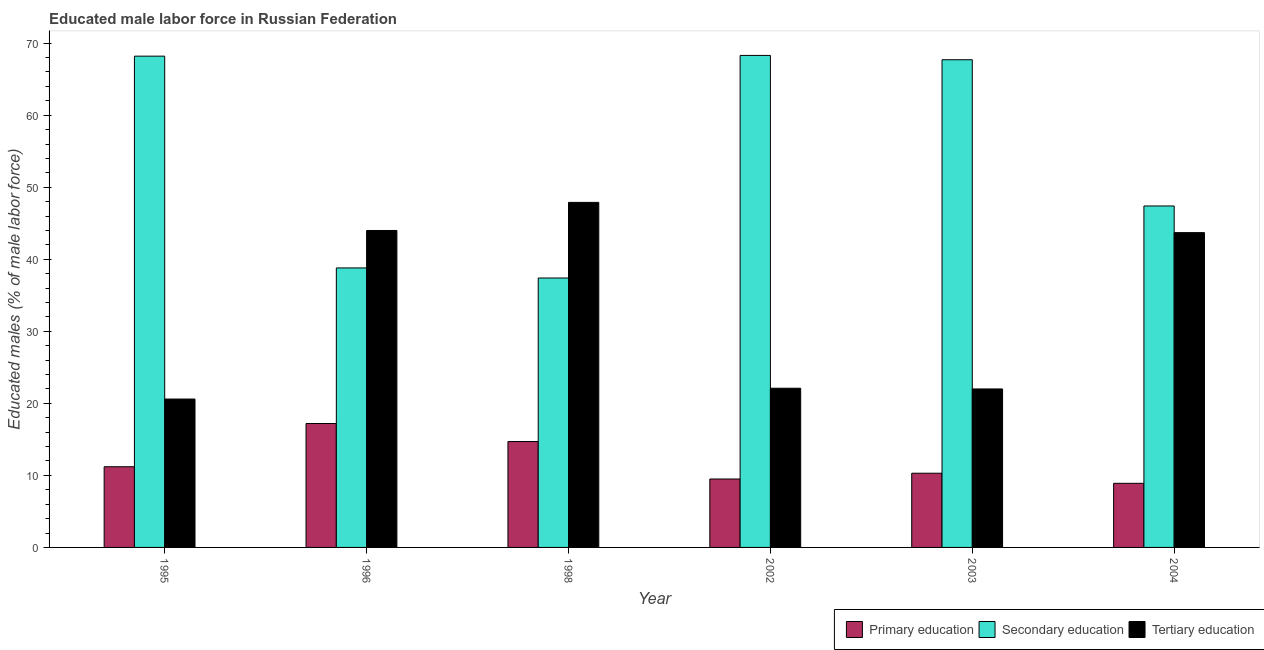How many different coloured bars are there?
Your answer should be compact. 3. How many bars are there on the 6th tick from the left?
Offer a terse response. 3. What is the label of the 3rd group of bars from the left?
Offer a terse response. 1998. In how many cases, is the number of bars for a given year not equal to the number of legend labels?
Give a very brief answer. 0. What is the percentage of male labor force who received primary education in 2003?
Offer a terse response. 10.3. Across all years, what is the maximum percentage of male labor force who received secondary education?
Your response must be concise. 68.3. Across all years, what is the minimum percentage of male labor force who received primary education?
Keep it short and to the point. 8.9. In which year was the percentage of male labor force who received secondary education minimum?
Offer a terse response. 1998. What is the total percentage of male labor force who received secondary education in the graph?
Keep it short and to the point. 327.8. What is the difference between the percentage of male labor force who received primary education in 1995 and that in 2004?
Provide a succinct answer. 2.3. What is the difference between the percentage of male labor force who received primary education in 1995 and the percentage of male labor force who received secondary education in 2002?
Your answer should be compact. 1.7. What is the average percentage of male labor force who received primary education per year?
Offer a very short reply. 11.97. In the year 1996, what is the difference between the percentage of male labor force who received primary education and percentage of male labor force who received tertiary education?
Your answer should be compact. 0. In how many years, is the percentage of male labor force who received secondary education greater than 40 %?
Your response must be concise. 4. What is the ratio of the percentage of male labor force who received tertiary education in 1998 to that in 2002?
Provide a succinct answer. 2.17. Is the difference between the percentage of male labor force who received primary education in 1995 and 1996 greater than the difference between the percentage of male labor force who received tertiary education in 1995 and 1996?
Provide a succinct answer. No. What is the difference between the highest and the second highest percentage of male labor force who received primary education?
Your answer should be very brief. 2.5. What is the difference between the highest and the lowest percentage of male labor force who received secondary education?
Ensure brevity in your answer.  30.9. In how many years, is the percentage of male labor force who received secondary education greater than the average percentage of male labor force who received secondary education taken over all years?
Provide a succinct answer. 3. What does the 2nd bar from the right in 1995 represents?
Your response must be concise. Secondary education. How many years are there in the graph?
Provide a short and direct response. 6. Are the values on the major ticks of Y-axis written in scientific E-notation?
Keep it short and to the point. No. Does the graph contain any zero values?
Provide a succinct answer. No. What is the title of the graph?
Keep it short and to the point. Educated male labor force in Russian Federation. What is the label or title of the X-axis?
Your response must be concise. Year. What is the label or title of the Y-axis?
Your answer should be compact. Educated males (% of male labor force). What is the Educated males (% of male labor force) in Primary education in 1995?
Ensure brevity in your answer.  11.2. What is the Educated males (% of male labor force) in Secondary education in 1995?
Ensure brevity in your answer.  68.2. What is the Educated males (% of male labor force) in Tertiary education in 1995?
Provide a short and direct response. 20.6. What is the Educated males (% of male labor force) in Primary education in 1996?
Keep it short and to the point. 17.2. What is the Educated males (% of male labor force) in Secondary education in 1996?
Your answer should be compact. 38.8. What is the Educated males (% of male labor force) in Tertiary education in 1996?
Give a very brief answer. 44. What is the Educated males (% of male labor force) of Primary education in 1998?
Your response must be concise. 14.7. What is the Educated males (% of male labor force) of Secondary education in 1998?
Your response must be concise. 37.4. What is the Educated males (% of male labor force) of Tertiary education in 1998?
Provide a short and direct response. 47.9. What is the Educated males (% of male labor force) in Primary education in 2002?
Your response must be concise. 9.5. What is the Educated males (% of male labor force) of Secondary education in 2002?
Your answer should be very brief. 68.3. What is the Educated males (% of male labor force) in Tertiary education in 2002?
Make the answer very short. 22.1. What is the Educated males (% of male labor force) of Primary education in 2003?
Keep it short and to the point. 10.3. What is the Educated males (% of male labor force) in Secondary education in 2003?
Offer a terse response. 67.7. What is the Educated males (% of male labor force) in Tertiary education in 2003?
Your response must be concise. 22. What is the Educated males (% of male labor force) of Primary education in 2004?
Your response must be concise. 8.9. What is the Educated males (% of male labor force) in Secondary education in 2004?
Give a very brief answer. 47.4. What is the Educated males (% of male labor force) of Tertiary education in 2004?
Your answer should be compact. 43.7. Across all years, what is the maximum Educated males (% of male labor force) in Primary education?
Provide a short and direct response. 17.2. Across all years, what is the maximum Educated males (% of male labor force) in Secondary education?
Give a very brief answer. 68.3. Across all years, what is the maximum Educated males (% of male labor force) of Tertiary education?
Your response must be concise. 47.9. Across all years, what is the minimum Educated males (% of male labor force) in Primary education?
Your response must be concise. 8.9. Across all years, what is the minimum Educated males (% of male labor force) in Secondary education?
Provide a succinct answer. 37.4. Across all years, what is the minimum Educated males (% of male labor force) of Tertiary education?
Provide a short and direct response. 20.6. What is the total Educated males (% of male labor force) in Primary education in the graph?
Offer a terse response. 71.8. What is the total Educated males (% of male labor force) in Secondary education in the graph?
Ensure brevity in your answer.  327.8. What is the total Educated males (% of male labor force) of Tertiary education in the graph?
Your answer should be very brief. 200.3. What is the difference between the Educated males (% of male labor force) in Secondary education in 1995 and that in 1996?
Your answer should be very brief. 29.4. What is the difference between the Educated males (% of male labor force) in Tertiary education in 1995 and that in 1996?
Offer a very short reply. -23.4. What is the difference between the Educated males (% of male labor force) of Primary education in 1995 and that in 1998?
Your answer should be compact. -3.5. What is the difference between the Educated males (% of male labor force) in Secondary education in 1995 and that in 1998?
Give a very brief answer. 30.8. What is the difference between the Educated males (% of male labor force) of Tertiary education in 1995 and that in 1998?
Your response must be concise. -27.3. What is the difference between the Educated males (% of male labor force) of Secondary education in 1995 and that in 2002?
Provide a short and direct response. -0.1. What is the difference between the Educated males (% of male labor force) of Secondary education in 1995 and that in 2003?
Make the answer very short. 0.5. What is the difference between the Educated males (% of male labor force) in Primary education in 1995 and that in 2004?
Offer a terse response. 2.3. What is the difference between the Educated males (% of male labor force) in Secondary education in 1995 and that in 2004?
Your response must be concise. 20.8. What is the difference between the Educated males (% of male labor force) of Tertiary education in 1995 and that in 2004?
Keep it short and to the point. -23.1. What is the difference between the Educated males (% of male labor force) in Primary education in 1996 and that in 1998?
Your answer should be very brief. 2.5. What is the difference between the Educated males (% of male labor force) in Secondary education in 1996 and that in 2002?
Ensure brevity in your answer.  -29.5. What is the difference between the Educated males (% of male labor force) of Tertiary education in 1996 and that in 2002?
Your answer should be very brief. 21.9. What is the difference between the Educated males (% of male labor force) of Secondary education in 1996 and that in 2003?
Give a very brief answer. -28.9. What is the difference between the Educated males (% of male labor force) in Secondary education in 1996 and that in 2004?
Provide a short and direct response. -8.6. What is the difference between the Educated males (% of male labor force) in Secondary education in 1998 and that in 2002?
Give a very brief answer. -30.9. What is the difference between the Educated males (% of male labor force) of Tertiary education in 1998 and that in 2002?
Offer a very short reply. 25.8. What is the difference between the Educated males (% of male labor force) of Primary education in 1998 and that in 2003?
Make the answer very short. 4.4. What is the difference between the Educated males (% of male labor force) of Secondary education in 1998 and that in 2003?
Ensure brevity in your answer.  -30.3. What is the difference between the Educated males (% of male labor force) of Tertiary education in 1998 and that in 2003?
Give a very brief answer. 25.9. What is the difference between the Educated males (% of male labor force) of Primary education in 1998 and that in 2004?
Your response must be concise. 5.8. What is the difference between the Educated males (% of male labor force) in Tertiary education in 1998 and that in 2004?
Your response must be concise. 4.2. What is the difference between the Educated males (% of male labor force) of Primary education in 2002 and that in 2003?
Your answer should be compact. -0.8. What is the difference between the Educated males (% of male labor force) of Secondary education in 2002 and that in 2003?
Keep it short and to the point. 0.6. What is the difference between the Educated males (% of male labor force) in Secondary education in 2002 and that in 2004?
Provide a short and direct response. 20.9. What is the difference between the Educated males (% of male labor force) in Tertiary education in 2002 and that in 2004?
Your answer should be very brief. -21.6. What is the difference between the Educated males (% of male labor force) in Secondary education in 2003 and that in 2004?
Your answer should be very brief. 20.3. What is the difference between the Educated males (% of male labor force) of Tertiary education in 2003 and that in 2004?
Keep it short and to the point. -21.7. What is the difference between the Educated males (% of male labor force) of Primary education in 1995 and the Educated males (% of male labor force) of Secondary education in 1996?
Your response must be concise. -27.6. What is the difference between the Educated males (% of male labor force) of Primary education in 1995 and the Educated males (% of male labor force) of Tertiary education in 1996?
Ensure brevity in your answer.  -32.8. What is the difference between the Educated males (% of male labor force) of Secondary education in 1995 and the Educated males (% of male labor force) of Tertiary education in 1996?
Keep it short and to the point. 24.2. What is the difference between the Educated males (% of male labor force) in Primary education in 1995 and the Educated males (% of male labor force) in Secondary education in 1998?
Give a very brief answer. -26.2. What is the difference between the Educated males (% of male labor force) in Primary education in 1995 and the Educated males (% of male labor force) in Tertiary education in 1998?
Keep it short and to the point. -36.7. What is the difference between the Educated males (% of male labor force) in Secondary education in 1995 and the Educated males (% of male labor force) in Tertiary education in 1998?
Make the answer very short. 20.3. What is the difference between the Educated males (% of male labor force) in Primary education in 1995 and the Educated males (% of male labor force) in Secondary education in 2002?
Make the answer very short. -57.1. What is the difference between the Educated males (% of male labor force) in Secondary education in 1995 and the Educated males (% of male labor force) in Tertiary education in 2002?
Your answer should be compact. 46.1. What is the difference between the Educated males (% of male labor force) in Primary education in 1995 and the Educated males (% of male labor force) in Secondary education in 2003?
Provide a succinct answer. -56.5. What is the difference between the Educated males (% of male labor force) of Primary education in 1995 and the Educated males (% of male labor force) of Tertiary education in 2003?
Make the answer very short. -10.8. What is the difference between the Educated males (% of male labor force) of Secondary education in 1995 and the Educated males (% of male labor force) of Tertiary education in 2003?
Give a very brief answer. 46.2. What is the difference between the Educated males (% of male labor force) in Primary education in 1995 and the Educated males (% of male labor force) in Secondary education in 2004?
Make the answer very short. -36.2. What is the difference between the Educated males (% of male labor force) of Primary education in 1995 and the Educated males (% of male labor force) of Tertiary education in 2004?
Give a very brief answer. -32.5. What is the difference between the Educated males (% of male labor force) in Primary education in 1996 and the Educated males (% of male labor force) in Secondary education in 1998?
Your answer should be very brief. -20.2. What is the difference between the Educated males (% of male labor force) of Primary education in 1996 and the Educated males (% of male labor force) of Tertiary education in 1998?
Your answer should be very brief. -30.7. What is the difference between the Educated males (% of male labor force) in Secondary education in 1996 and the Educated males (% of male labor force) in Tertiary education in 1998?
Provide a succinct answer. -9.1. What is the difference between the Educated males (% of male labor force) of Primary education in 1996 and the Educated males (% of male labor force) of Secondary education in 2002?
Provide a short and direct response. -51.1. What is the difference between the Educated males (% of male labor force) of Primary education in 1996 and the Educated males (% of male labor force) of Tertiary education in 2002?
Make the answer very short. -4.9. What is the difference between the Educated males (% of male labor force) in Secondary education in 1996 and the Educated males (% of male labor force) in Tertiary education in 2002?
Provide a short and direct response. 16.7. What is the difference between the Educated males (% of male labor force) of Primary education in 1996 and the Educated males (% of male labor force) of Secondary education in 2003?
Offer a very short reply. -50.5. What is the difference between the Educated males (% of male labor force) in Primary education in 1996 and the Educated males (% of male labor force) in Secondary education in 2004?
Provide a short and direct response. -30.2. What is the difference between the Educated males (% of male labor force) of Primary education in 1996 and the Educated males (% of male labor force) of Tertiary education in 2004?
Keep it short and to the point. -26.5. What is the difference between the Educated males (% of male labor force) of Secondary education in 1996 and the Educated males (% of male labor force) of Tertiary education in 2004?
Ensure brevity in your answer.  -4.9. What is the difference between the Educated males (% of male labor force) in Primary education in 1998 and the Educated males (% of male labor force) in Secondary education in 2002?
Your answer should be very brief. -53.6. What is the difference between the Educated males (% of male labor force) of Primary education in 1998 and the Educated males (% of male labor force) of Tertiary education in 2002?
Your response must be concise. -7.4. What is the difference between the Educated males (% of male labor force) of Secondary education in 1998 and the Educated males (% of male labor force) of Tertiary education in 2002?
Offer a very short reply. 15.3. What is the difference between the Educated males (% of male labor force) in Primary education in 1998 and the Educated males (% of male labor force) in Secondary education in 2003?
Offer a terse response. -53. What is the difference between the Educated males (% of male labor force) in Secondary education in 1998 and the Educated males (% of male labor force) in Tertiary education in 2003?
Offer a very short reply. 15.4. What is the difference between the Educated males (% of male labor force) in Primary education in 1998 and the Educated males (% of male labor force) in Secondary education in 2004?
Your answer should be compact. -32.7. What is the difference between the Educated males (% of male labor force) of Primary education in 1998 and the Educated males (% of male labor force) of Tertiary education in 2004?
Give a very brief answer. -29. What is the difference between the Educated males (% of male labor force) in Primary education in 2002 and the Educated males (% of male labor force) in Secondary education in 2003?
Your answer should be very brief. -58.2. What is the difference between the Educated males (% of male labor force) of Secondary education in 2002 and the Educated males (% of male labor force) of Tertiary education in 2003?
Ensure brevity in your answer.  46.3. What is the difference between the Educated males (% of male labor force) of Primary education in 2002 and the Educated males (% of male labor force) of Secondary education in 2004?
Provide a short and direct response. -37.9. What is the difference between the Educated males (% of male labor force) of Primary education in 2002 and the Educated males (% of male labor force) of Tertiary education in 2004?
Provide a succinct answer. -34.2. What is the difference between the Educated males (% of male labor force) of Secondary education in 2002 and the Educated males (% of male labor force) of Tertiary education in 2004?
Your response must be concise. 24.6. What is the difference between the Educated males (% of male labor force) of Primary education in 2003 and the Educated males (% of male labor force) of Secondary education in 2004?
Your answer should be compact. -37.1. What is the difference between the Educated males (% of male labor force) of Primary education in 2003 and the Educated males (% of male labor force) of Tertiary education in 2004?
Your response must be concise. -33.4. What is the difference between the Educated males (% of male labor force) in Secondary education in 2003 and the Educated males (% of male labor force) in Tertiary education in 2004?
Your response must be concise. 24. What is the average Educated males (% of male labor force) in Primary education per year?
Your answer should be very brief. 11.97. What is the average Educated males (% of male labor force) in Secondary education per year?
Ensure brevity in your answer.  54.63. What is the average Educated males (% of male labor force) in Tertiary education per year?
Keep it short and to the point. 33.38. In the year 1995, what is the difference between the Educated males (% of male labor force) in Primary education and Educated males (% of male labor force) in Secondary education?
Provide a short and direct response. -57. In the year 1995, what is the difference between the Educated males (% of male labor force) in Primary education and Educated males (% of male labor force) in Tertiary education?
Make the answer very short. -9.4. In the year 1995, what is the difference between the Educated males (% of male labor force) of Secondary education and Educated males (% of male labor force) of Tertiary education?
Give a very brief answer. 47.6. In the year 1996, what is the difference between the Educated males (% of male labor force) of Primary education and Educated males (% of male labor force) of Secondary education?
Offer a very short reply. -21.6. In the year 1996, what is the difference between the Educated males (% of male labor force) in Primary education and Educated males (% of male labor force) in Tertiary education?
Offer a very short reply. -26.8. In the year 1996, what is the difference between the Educated males (% of male labor force) in Secondary education and Educated males (% of male labor force) in Tertiary education?
Your response must be concise. -5.2. In the year 1998, what is the difference between the Educated males (% of male labor force) in Primary education and Educated males (% of male labor force) in Secondary education?
Your response must be concise. -22.7. In the year 1998, what is the difference between the Educated males (% of male labor force) in Primary education and Educated males (% of male labor force) in Tertiary education?
Provide a succinct answer. -33.2. In the year 2002, what is the difference between the Educated males (% of male labor force) in Primary education and Educated males (% of male labor force) in Secondary education?
Provide a short and direct response. -58.8. In the year 2002, what is the difference between the Educated males (% of male labor force) of Secondary education and Educated males (% of male labor force) of Tertiary education?
Give a very brief answer. 46.2. In the year 2003, what is the difference between the Educated males (% of male labor force) in Primary education and Educated males (% of male labor force) in Secondary education?
Offer a terse response. -57.4. In the year 2003, what is the difference between the Educated males (% of male labor force) in Primary education and Educated males (% of male labor force) in Tertiary education?
Provide a succinct answer. -11.7. In the year 2003, what is the difference between the Educated males (% of male labor force) in Secondary education and Educated males (% of male labor force) in Tertiary education?
Give a very brief answer. 45.7. In the year 2004, what is the difference between the Educated males (% of male labor force) of Primary education and Educated males (% of male labor force) of Secondary education?
Offer a terse response. -38.5. In the year 2004, what is the difference between the Educated males (% of male labor force) of Primary education and Educated males (% of male labor force) of Tertiary education?
Keep it short and to the point. -34.8. In the year 2004, what is the difference between the Educated males (% of male labor force) of Secondary education and Educated males (% of male labor force) of Tertiary education?
Ensure brevity in your answer.  3.7. What is the ratio of the Educated males (% of male labor force) of Primary education in 1995 to that in 1996?
Give a very brief answer. 0.65. What is the ratio of the Educated males (% of male labor force) of Secondary education in 1995 to that in 1996?
Your answer should be compact. 1.76. What is the ratio of the Educated males (% of male labor force) in Tertiary education in 1995 to that in 1996?
Offer a very short reply. 0.47. What is the ratio of the Educated males (% of male labor force) of Primary education in 1995 to that in 1998?
Make the answer very short. 0.76. What is the ratio of the Educated males (% of male labor force) in Secondary education in 1995 to that in 1998?
Ensure brevity in your answer.  1.82. What is the ratio of the Educated males (% of male labor force) in Tertiary education in 1995 to that in 1998?
Your response must be concise. 0.43. What is the ratio of the Educated males (% of male labor force) of Primary education in 1995 to that in 2002?
Offer a very short reply. 1.18. What is the ratio of the Educated males (% of male labor force) of Secondary education in 1995 to that in 2002?
Provide a short and direct response. 1. What is the ratio of the Educated males (% of male labor force) of Tertiary education in 1995 to that in 2002?
Offer a terse response. 0.93. What is the ratio of the Educated males (% of male labor force) in Primary education in 1995 to that in 2003?
Offer a very short reply. 1.09. What is the ratio of the Educated males (% of male labor force) in Secondary education in 1995 to that in 2003?
Your answer should be compact. 1.01. What is the ratio of the Educated males (% of male labor force) of Tertiary education in 1995 to that in 2003?
Offer a very short reply. 0.94. What is the ratio of the Educated males (% of male labor force) in Primary education in 1995 to that in 2004?
Offer a very short reply. 1.26. What is the ratio of the Educated males (% of male labor force) in Secondary education in 1995 to that in 2004?
Your response must be concise. 1.44. What is the ratio of the Educated males (% of male labor force) of Tertiary education in 1995 to that in 2004?
Keep it short and to the point. 0.47. What is the ratio of the Educated males (% of male labor force) in Primary education in 1996 to that in 1998?
Keep it short and to the point. 1.17. What is the ratio of the Educated males (% of male labor force) in Secondary education in 1996 to that in 1998?
Keep it short and to the point. 1.04. What is the ratio of the Educated males (% of male labor force) of Tertiary education in 1996 to that in 1998?
Your response must be concise. 0.92. What is the ratio of the Educated males (% of male labor force) in Primary education in 1996 to that in 2002?
Your answer should be compact. 1.81. What is the ratio of the Educated males (% of male labor force) of Secondary education in 1996 to that in 2002?
Provide a succinct answer. 0.57. What is the ratio of the Educated males (% of male labor force) in Tertiary education in 1996 to that in 2002?
Your response must be concise. 1.99. What is the ratio of the Educated males (% of male labor force) in Primary education in 1996 to that in 2003?
Keep it short and to the point. 1.67. What is the ratio of the Educated males (% of male labor force) of Secondary education in 1996 to that in 2003?
Give a very brief answer. 0.57. What is the ratio of the Educated males (% of male labor force) in Tertiary education in 1996 to that in 2003?
Your answer should be very brief. 2. What is the ratio of the Educated males (% of male labor force) in Primary education in 1996 to that in 2004?
Your answer should be compact. 1.93. What is the ratio of the Educated males (% of male labor force) in Secondary education in 1996 to that in 2004?
Offer a very short reply. 0.82. What is the ratio of the Educated males (% of male labor force) in Tertiary education in 1996 to that in 2004?
Provide a short and direct response. 1.01. What is the ratio of the Educated males (% of male labor force) in Primary education in 1998 to that in 2002?
Offer a terse response. 1.55. What is the ratio of the Educated males (% of male labor force) of Secondary education in 1998 to that in 2002?
Your answer should be compact. 0.55. What is the ratio of the Educated males (% of male labor force) of Tertiary education in 1998 to that in 2002?
Keep it short and to the point. 2.17. What is the ratio of the Educated males (% of male labor force) of Primary education in 1998 to that in 2003?
Give a very brief answer. 1.43. What is the ratio of the Educated males (% of male labor force) in Secondary education in 1998 to that in 2003?
Provide a succinct answer. 0.55. What is the ratio of the Educated males (% of male labor force) in Tertiary education in 1998 to that in 2003?
Ensure brevity in your answer.  2.18. What is the ratio of the Educated males (% of male labor force) in Primary education in 1998 to that in 2004?
Your answer should be very brief. 1.65. What is the ratio of the Educated males (% of male labor force) in Secondary education in 1998 to that in 2004?
Your answer should be compact. 0.79. What is the ratio of the Educated males (% of male labor force) of Tertiary education in 1998 to that in 2004?
Your answer should be compact. 1.1. What is the ratio of the Educated males (% of male labor force) of Primary education in 2002 to that in 2003?
Offer a very short reply. 0.92. What is the ratio of the Educated males (% of male labor force) in Secondary education in 2002 to that in 2003?
Provide a succinct answer. 1.01. What is the ratio of the Educated males (% of male labor force) in Tertiary education in 2002 to that in 2003?
Offer a terse response. 1. What is the ratio of the Educated males (% of male labor force) of Primary education in 2002 to that in 2004?
Offer a terse response. 1.07. What is the ratio of the Educated males (% of male labor force) in Secondary education in 2002 to that in 2004?
Offer a terse response. 1.44. What is the ratio of the Educated males (% of male labor force) in Tertiary education in 2002 to that in 2004?
Offer a very short reply. 0.51. What is the ratio of the Educated males (% of male labor force) of Primary education in 2003 to that in 2004?
Make the answer very short. 1.16. What is the ratio of the Educated males (% of male labor force) in Secondary education in 2003 to that in 2004?
Give a very brief answer. 1.43. What is the ratio of the Educated males (% of male labor force) in Tertiary education in 2003 to that in 2004?
Ensure brevity in your answer.  0.5. What is the difference between the highest and the second highest Educated males (% of male labor force) in Tertiary education?
Make the answer very short. 3.9. What is the difference between the highest and the lowest Educated males (% of male labor force) of Secondary education?
Make the answer very short. 30.9. What is the difference between the highest and the lowest Educated males (% of male labor force) of Tertiary education?
Give a very brief answer. 27.3. 